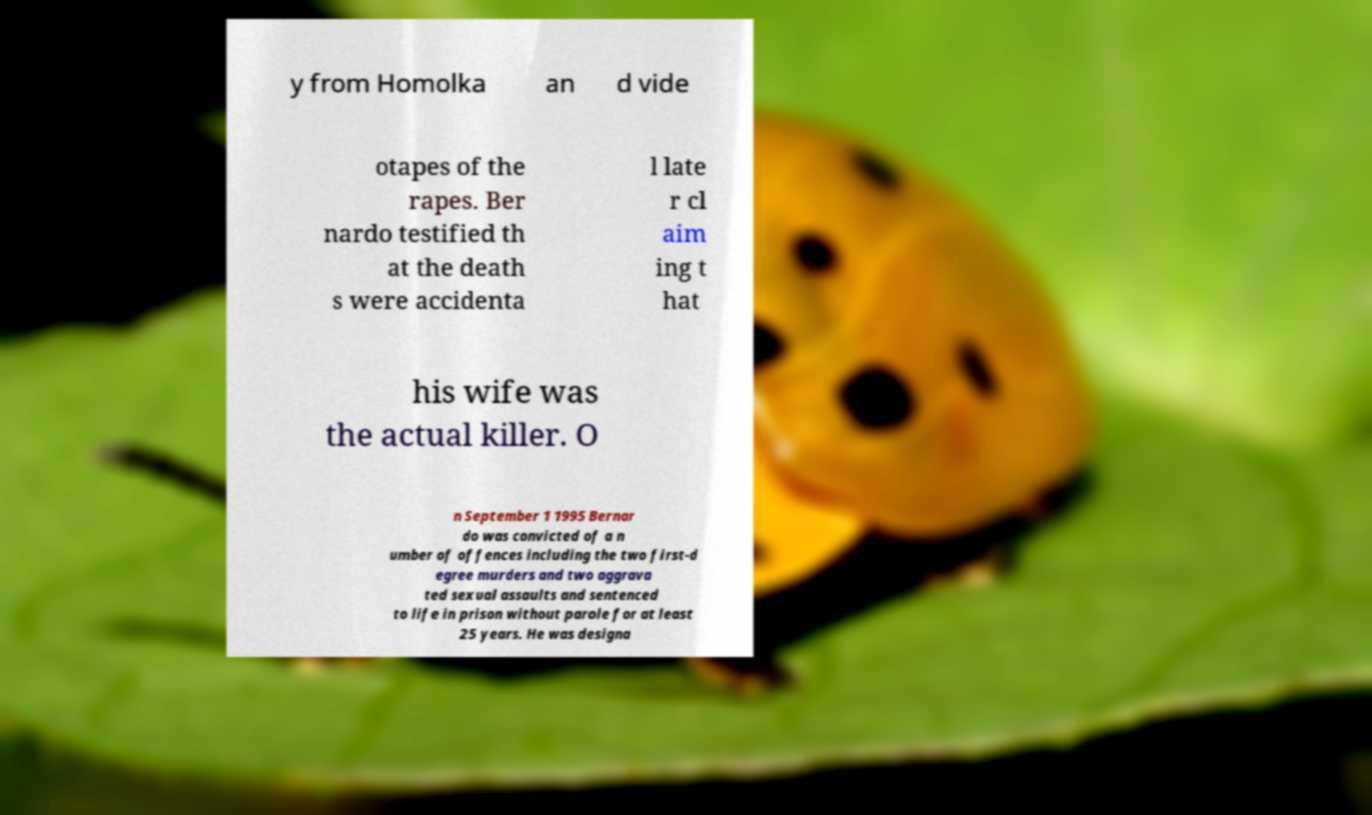Could you assist in decoding the text presented in this image and type it out clearly? y from Homolka an d vide otapes of the rapes. Ber nardo testified th at the death s were accidenta l late r cl aim ing t hat his wife was the actual killer. O n September 1 1995 Bernar do was convicted of a n umber of offences including the two first-d egree murders and two aggrava ted sexual assaults and sentenced to life in prison without parole for at least 25 years. He was designa 